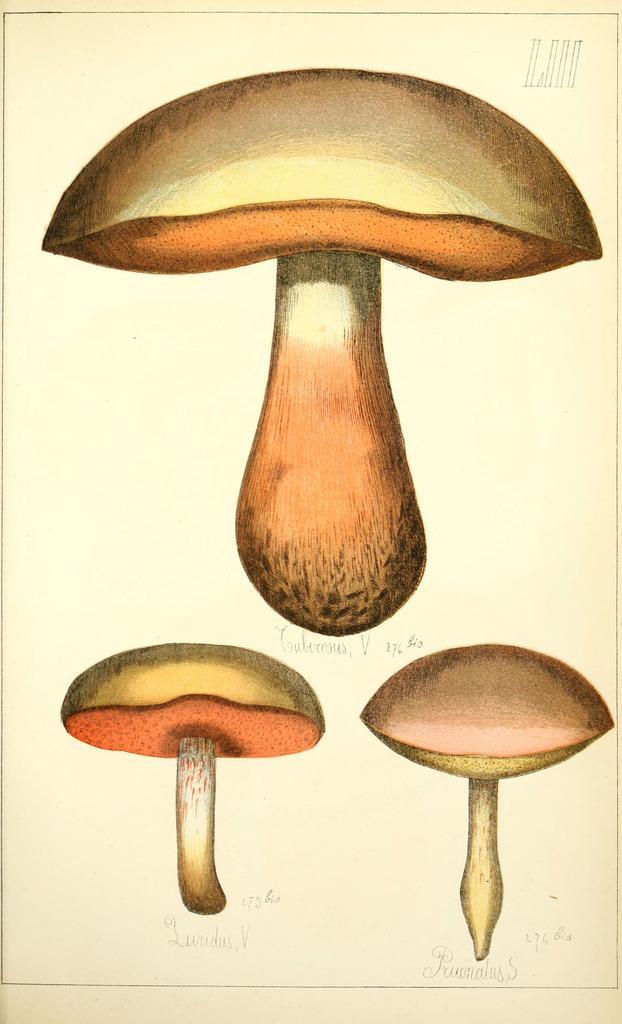Can you describe this image briefly? In this image we can see some mushroom pictures on a paper, also we can see some text on it. 